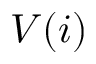<formula> <loc_0><loc_0><loc_500><loc_500>V ( i )</formula> 